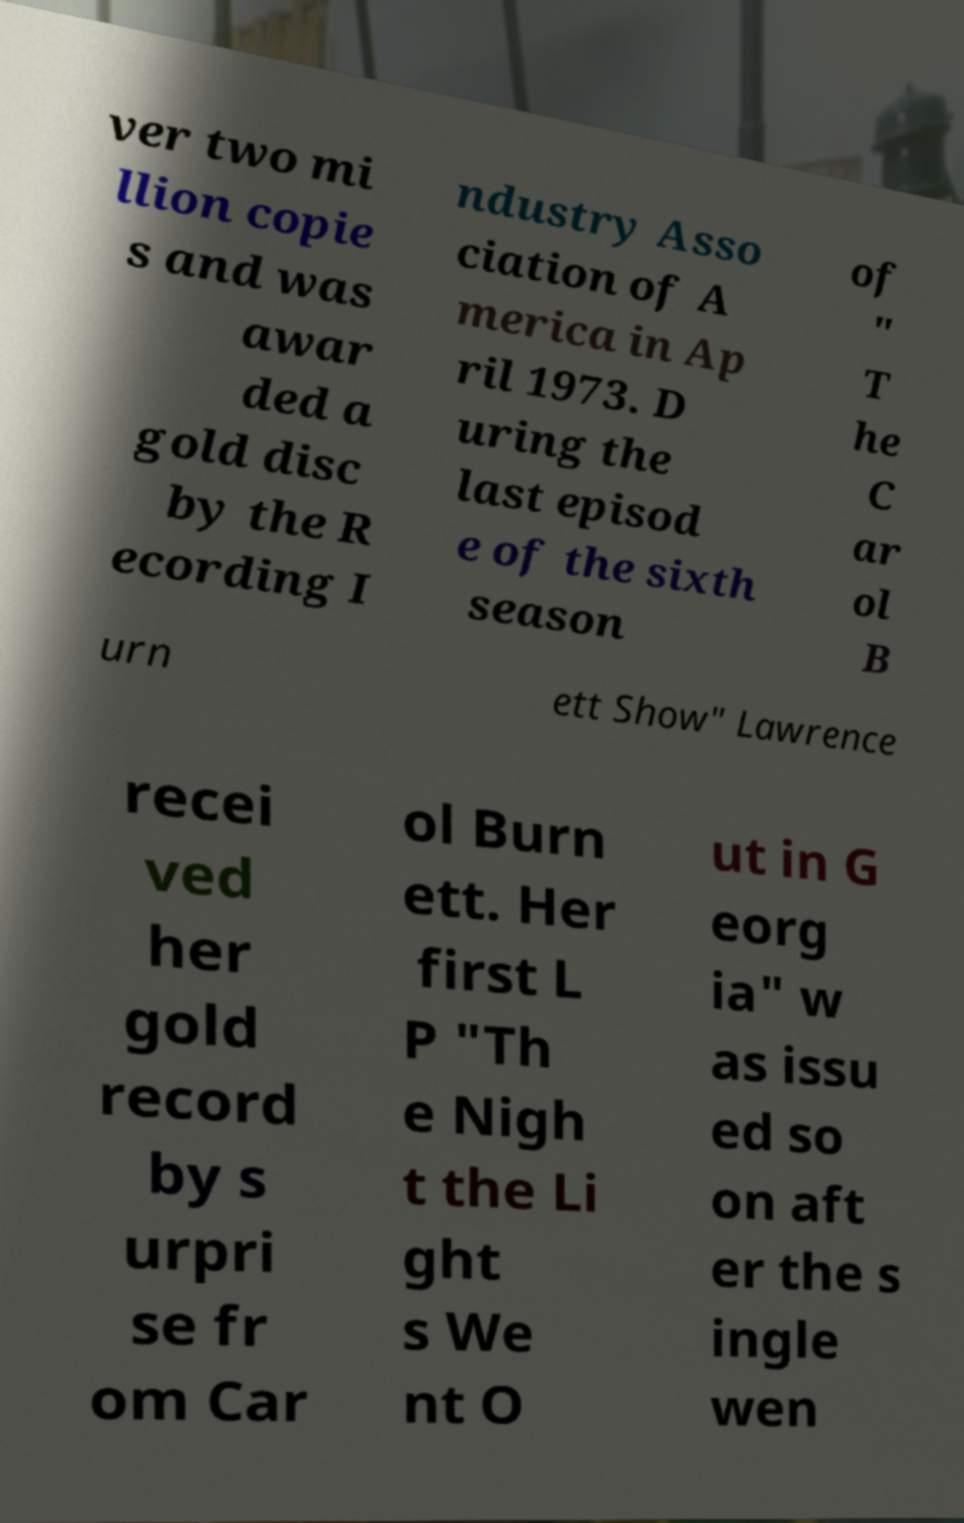Can you read and provide the text displayed in the image?This photo seems to have some interesting text. Can you extract and type it out for me? ver two mi llion copie s and was awar ded a gold disc by the R ecording I ndustry Asso ciation of A merica in Ap ril 1973. D uring the last episod e of the sixth season of " T he C ar ol B urn ett Show" Lawrence recei ved her gold record by s urpri se fr om Car ol Burn ett. Her first L P "Th e Nigh t the Li ght s We nt O ut in G eorg ia" w as issu ed so on aft er the s ingle wen 